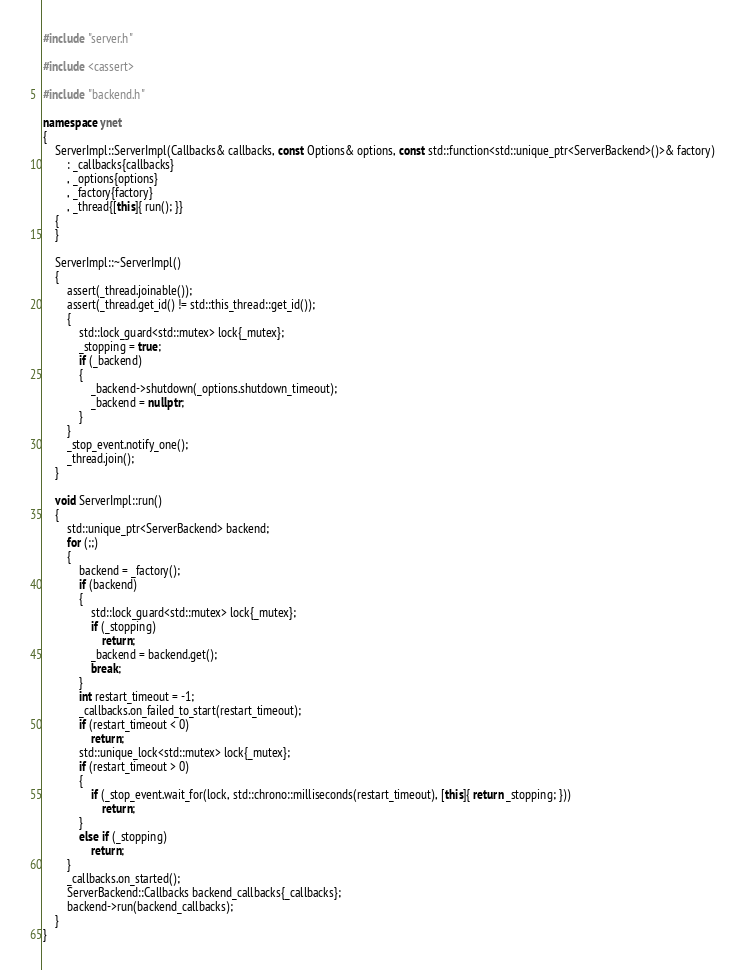Convert code to text. <code><loc_0><loc_0><loc_500><loc_500><_C++_>#include "server.h"

#include <cassert>

#include "backend.h"

namespace ynet
{
	ServerImpl::ServerImpl(Callbacks& callbacks, const Options& options, const std::function<std::unique_ptr<ServerBackend>()>& factory)
		: _callbacks{callbacks}
		, _options{options}
		, _factory{factory}
		, _thread{[this]{ run(); }}
	{
	}

	ServerImpl::~ServerImpl()
	{
		assert(_thread.joinable());
		assert(_thread.get_id() != std::this_thread::get_id());
		{
			std::lock_guard<std::mutex> lock{_mutex};
			_stopping = true;
			if (_backend)
			{
				_backend->shutdown(_options.shutdown_timeout);
				_backend = nullptr;
			}
		}
		_stop_event.notify_one();
		_thread.join();
	}

	void ServerImpl::run()
	{
		std::unique_ptr<ServerBackend> backend;
		for (;;)
		{
			backend = _factory();
			if (backend)
			{
				std::lock_guard<std::mutex> lock{_mutex};
				if (_stopping)
					return;
				_backend = backend.get();
				break;
			}
			int restart_timeout = -1;
			_callbacks.on_failed_to_start(restart_timeout);
			if (restart_timeout < 0)
				return;
			std::unique_lock<std::mutex> lock{_mutex};
			if (restart_timeout > 0)
			{
				if (_stop_event.wait_for(lock, std::chrono::milliseconds(restart_timeout), [this]{ return _stopping; }))
					return;
			}
			else if (_stopping)
				return;
		}
		_callbacks.on_started();
		ServerBackend::Callbacks backend_callbacks{_callbacks};
		backend->run(backend_callbacks);
	}
}
</code> 